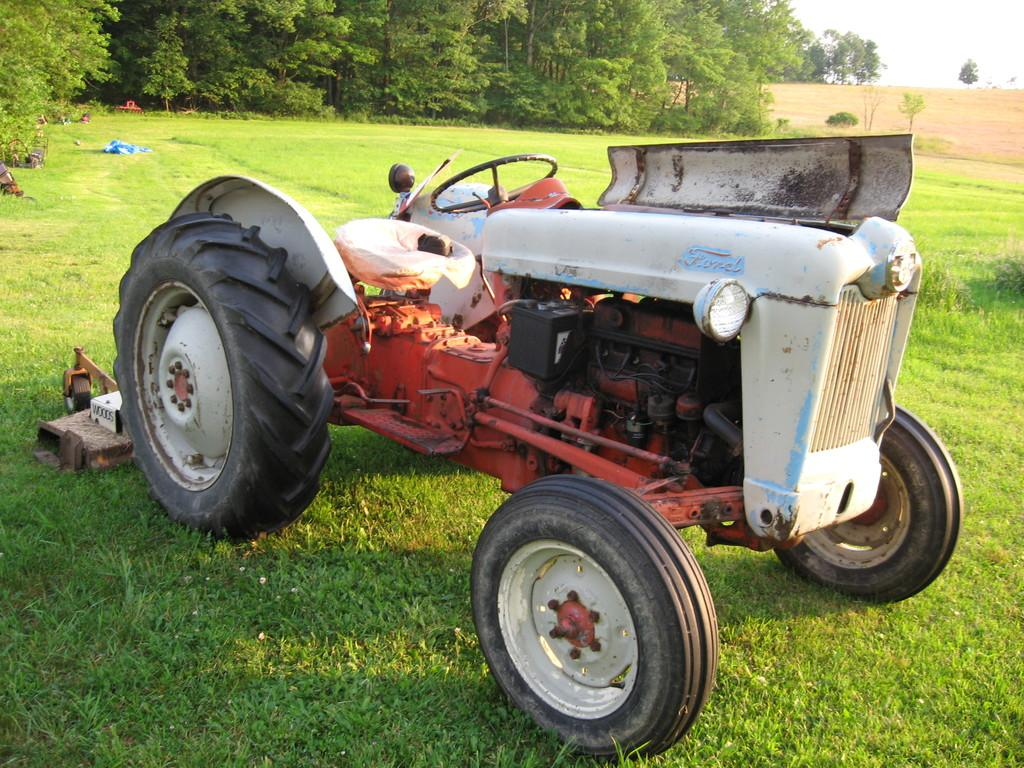What is the main subject of the picture? The main subject of the picture is a tractor. What can be seen in the background of the picture? There are trees, grass, and the sky visible in the background of the picture. What is the condition of the grass in the image? The grass is present in the background of the picture. What is located on the grass in the image? There are objects on the grass. What type of cushion can be seen providing punishment to the tractor in the image? There is no cushion or punishment present in the image; it features a tractor and objects on the grass. What type of attraction is depicted near the tractor in the image? There is no attraction depicted near the tractor in the image; it only features a tractor, trees, grass, and the sky. 